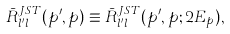Convert formula to latex. <formula><loc_0><loc_0><loc_500><loc_500>\bar { R } _ { l ^ { \prime } l } ^ { J S T } ( p ^ { \prime } , p ) \equiv \bar { R } _ { l ^ { \prime } l } ^ { J S T } ( p ^ { \prime } , p ; 2 E _ { p } ) ,</formula> 